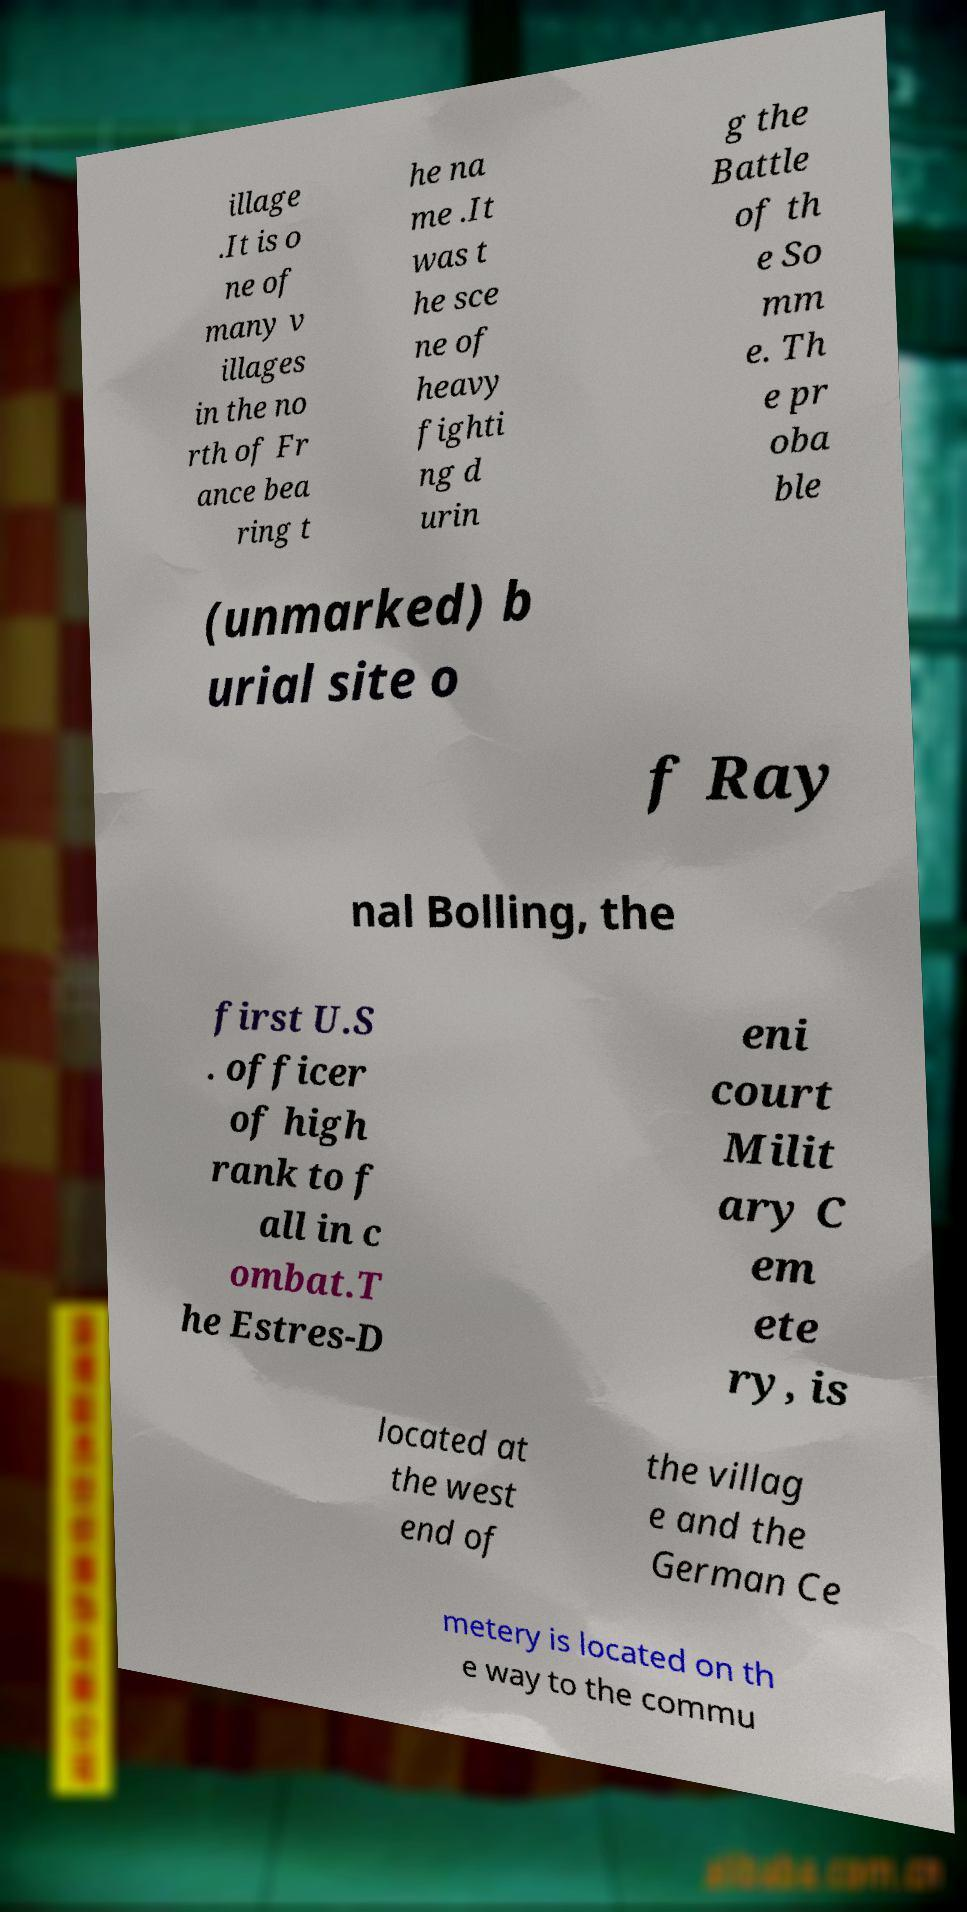Can you accurately transcribe the text from the provided image for me? illage .It is o ne of many v illages in the no rth of Fr ance bea ring t he na me .It was t he sce ne of heavy fighti ng d urin g the Battle of th e So mm e. Th e pr oba ble (unmarked) b urial site o f Ray nal Bolling, the first U.S . officer of high rank to f all in c ombat.T he Estres-D eni court Milit ary C em ete ry, is located at the west end of the villag e and the German Ce metery is located on th e way to the commu 